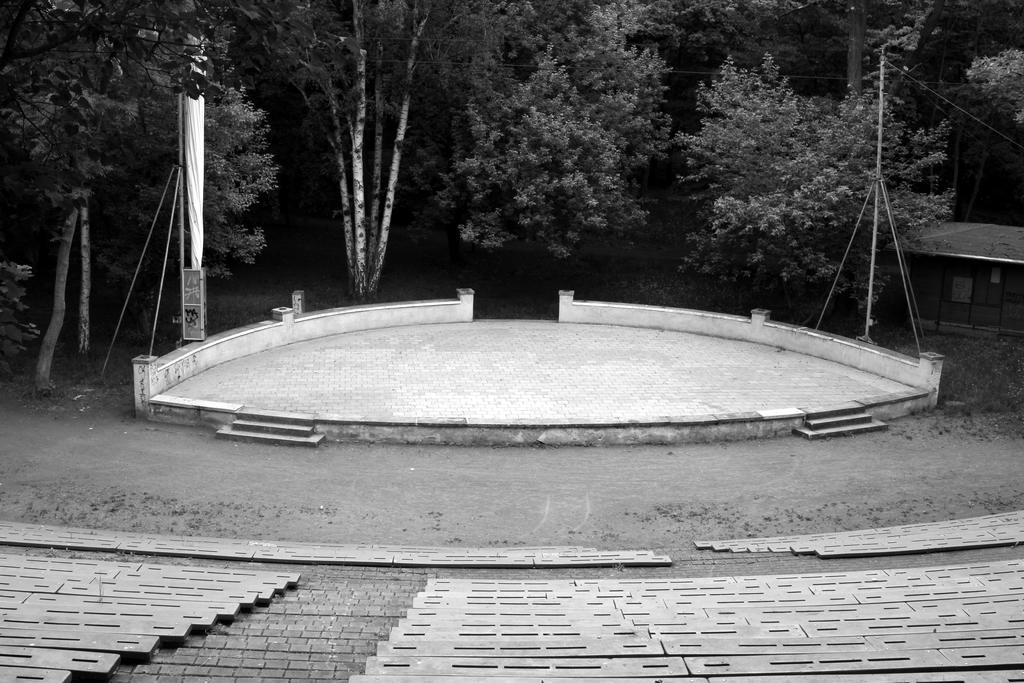What is the color scheme of the image? The image is black and white. What type of structure is in the image? There is an open-air auditorium in the image. Is there any other structure near the auditorium? Yes, there is a hut to the side of the auditorium. What can be seen in the background of the image? There are trees visible in the background of the image. What type of curtain is used to separate the audience from the stage in the image? There is no curtain visible in the image, as it is an open-air auditorium. What organization is responsible for managing the events in the auditorium in the image? The image does not provide information about the organization responsible for managing events in the auditorium. 